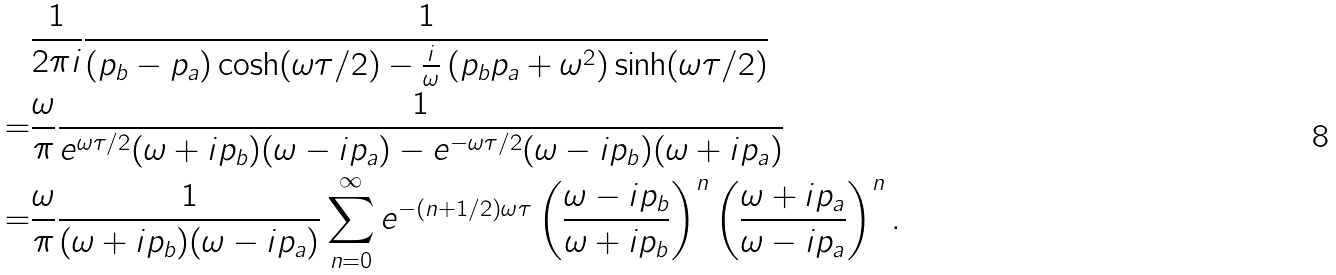<formula> <loc_0><loc_0><loc_500><loc_500>& \frac { 1 } { 2 \pi i } \frac { 1 } { ( p _ { b } - p _ { a } ) \cosh ( \omega \tau / 2 ) - \frac { i } { \omega } \left ( p _ { b } p _ { a } + \omega ^ { 2 } \right ) \sinh ( \omega \tau / 2 ) } \\ = & \frac { \omega } { \pi } \frac { 1 } { e ^ { \omega \tau / 2 } ( \omega + i p _ { b } ) ( \omega - i p _ { a } ) - e ^ { - \omega \tau / 2 } ( \omega - i p _ { b } ) ( \omega + i p _ { a } ) } \\ = & \frac { \omega } { \pi } \frac { 1 } { ( \omega + i p _ { b } ) ( \omega - i p _ { a } ) } \sum _ { n = 0 } ^ { \infty } e ^ { - ( n + 1 / 2 ) \omega \tau } \left ( \frac { \omega - i p _ { b } } { \omega + i p _ { b } } \right ) ^ { n } \left ( \frac { \omega + i p _ { a } } { \omega - i p _ { a } } \right ) ^ { n } .</formula> 